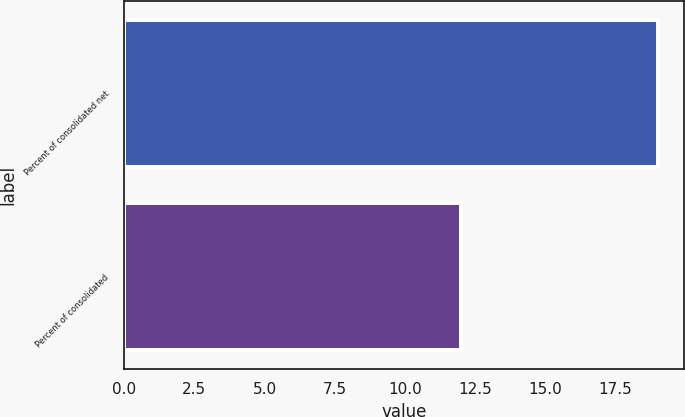<chart> <loc_0><loc_0><loc_500><loc_500><bar_chart><fcel>Percent of consolidated net<fcel>Percent of consolidated<nl><fcel>19<fcel>12<nl></chart> 